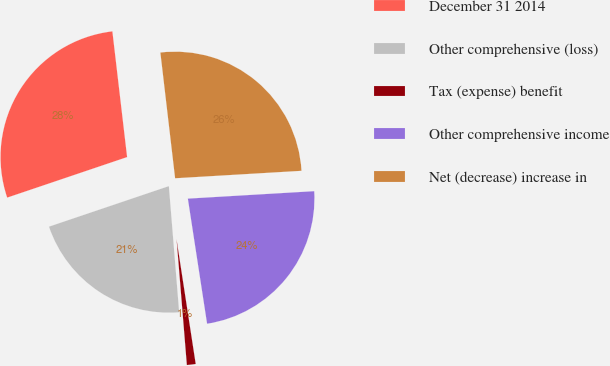<chart> <loc_0><loc_0><loc_500><loc_500><pie_chart><fcel>December 31 2014<fcel>Other comprehensive (loss)<fcel>Tax (expense) benefit<fcel>Other comprehensive income<fcel>Net (decrease) increase in<nl><fcel>28.33%<fcel>21.11%<fcel>1.13%<fcel>23.51%<fcel>25.92%<nl></chart> 